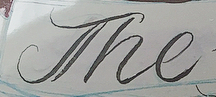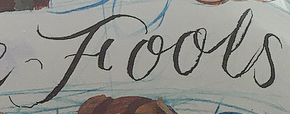What text is displayed in these images sequentially, separated by a semicolon? The; Fools 